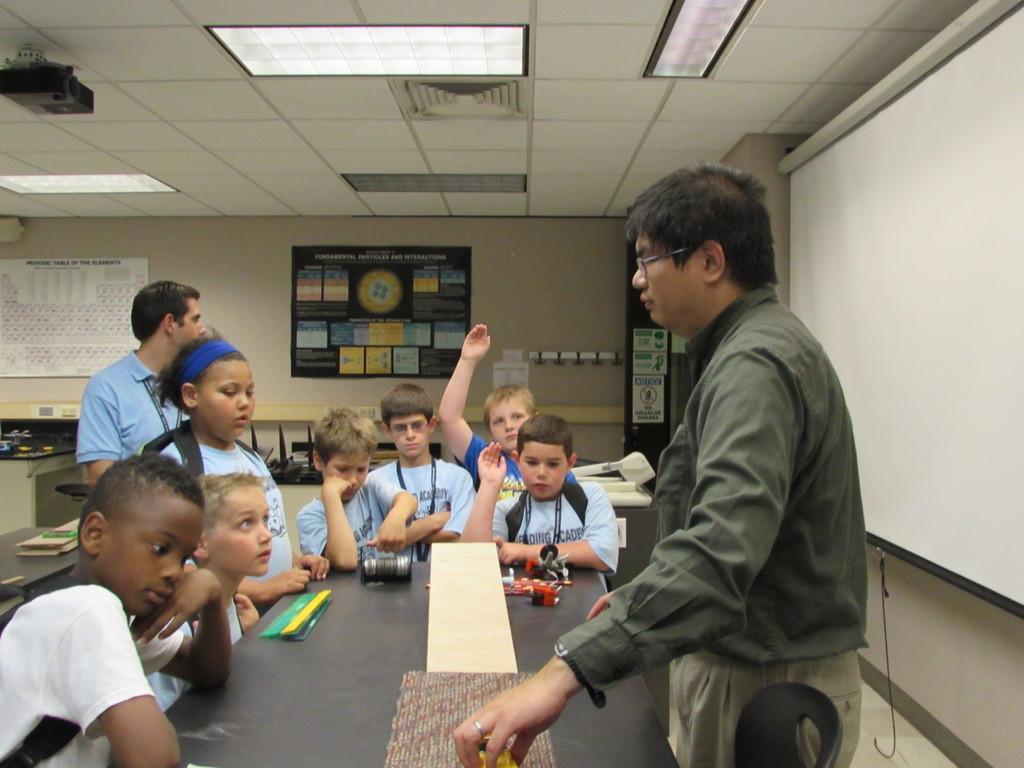Can you describe this image briefly? In this image we can see persons around the table. On the table there are some objects and book. On the right side of the image there is a screen. In the background there are posters, table, hanger and wall. At the top of the image there is a projector and lights. 